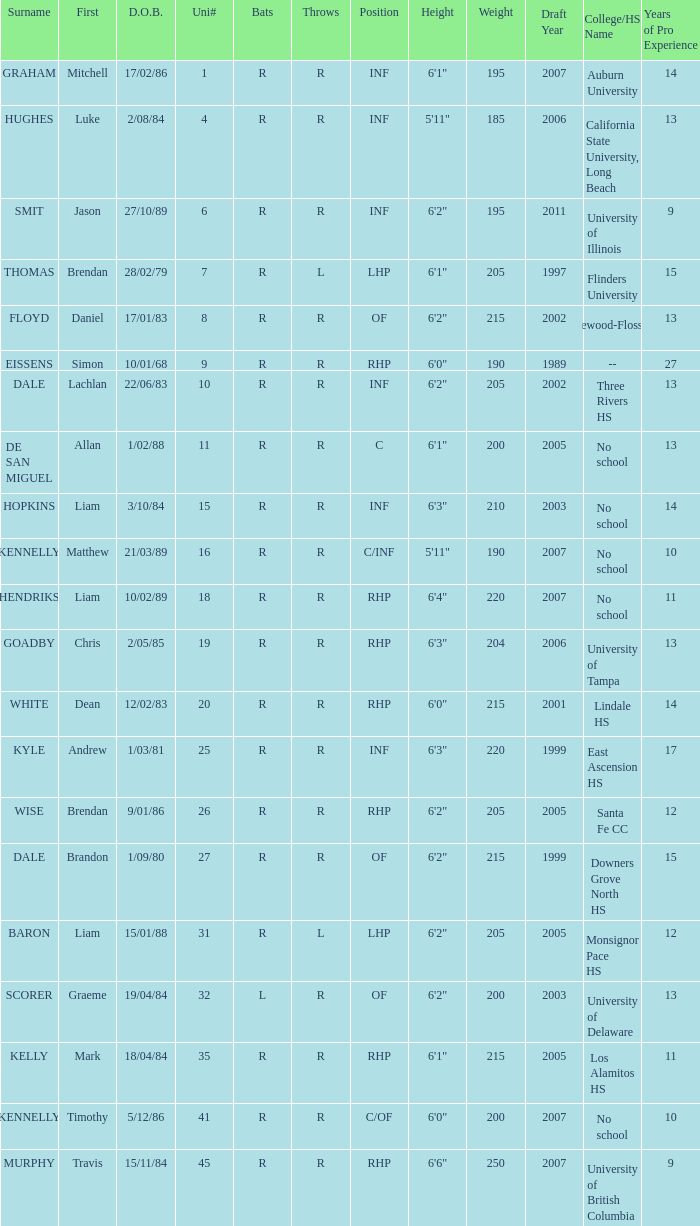Which batter has the last name Graham? R. 